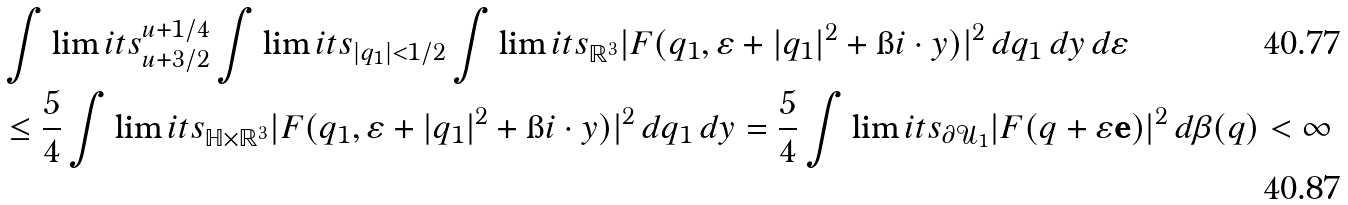Convert formula to latex. <formula><loc_0><loc_0><loc_500><loc_500>& \int \lim i t s _ { u + 3 / 2 } ^ { u + 1 / 4 } \int \lim i t s _ { | q _ { 1 } | < 1 / 2 } \int \lim i t s _ { \mathbb { R } ^ { 3 } } | F ( q _ { 1 } , \varepsilon + | q _ { 1 } | ^ { 2 } + \i i \cdot y ) | ^ { 2 } \, d q _ { 1 } \, d y \, d \varepsilon \\ & \leq \frac { 5 } { 4 } \int \lim i t s _ { \mathbb { H } \times \mathbb { R } ^ { 3 } } | F ( q _ { 1 } , \varepsilon + | q _ { 1 } | ^ { 2 } + \i i \cdot y ) | ^ { 2 } \, d q _ { 1 } \, d y = \frac { 5 } { 4 } \int \lim i t s _ { \partial \mathcal { U } _ { 1 } } | F ( q + \varepsilon \mathbf e ) | ^ { 2 } \, d \beta ( q ) < \infty</formula> 